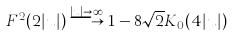Convert formula to latex. <formula><loc_0><loc_0><loc_500><loc_500>F ^ { 2 } ( 2 | u | ) \stackrel { | u | \rightarrow \infty } { \longrightarrow } 1 - 8 \sqrt { 2 } K _ { 0 } ( 4 | u | )</formula> 